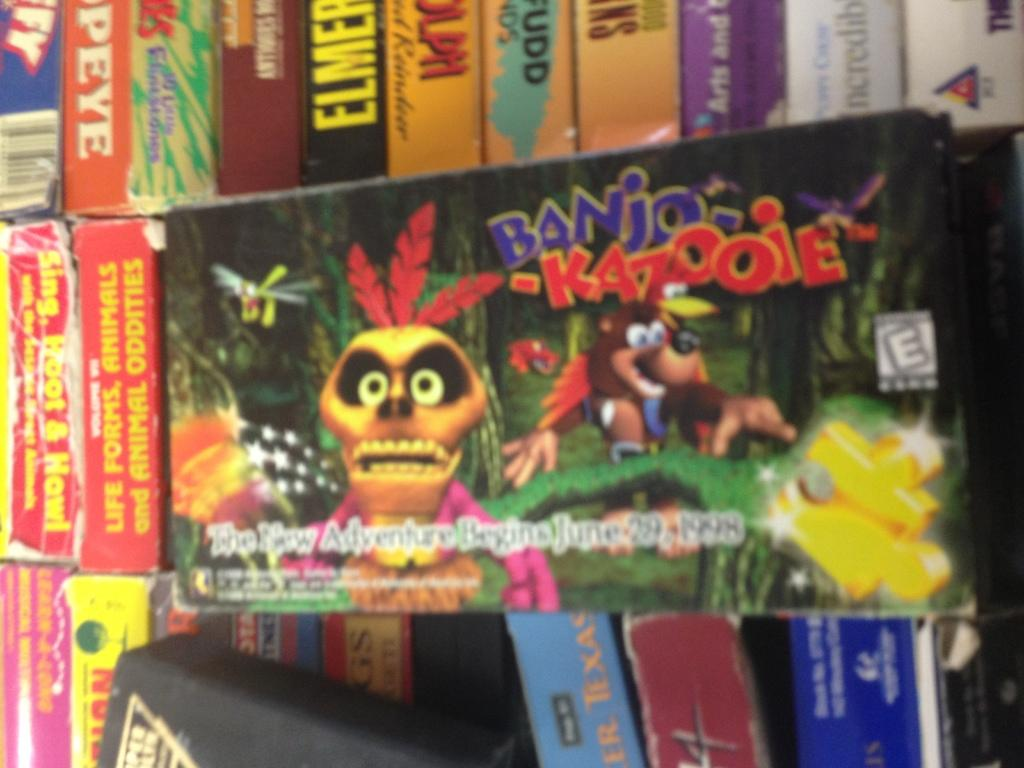<image>
Provide a brief description of the given image. A banner promoting Banjo Kazooie hangs in front of some games 